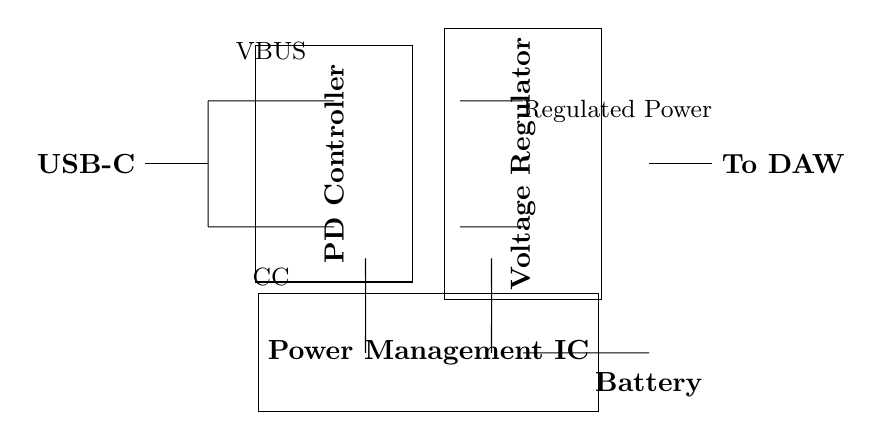What is the function of the PD Controller? The PD Controller (Power Delivery Controller) manages the negotiation of power levels and ensures that the correct power is delivered to connected devices.
Answer: Power management What component converts the voltage for device use? The Voltage Regulator adjusts the input voltage to a stable output voltage suitable for powering other components in the circuit.
Answer: Voltage Regulator What does VBUS represent in the circuit? VBUS is the line that carries the main power supply voltage in a USB connection and typically indicates a positive voltage level.
Answer: Main power supply How is the circuit powered? The circuit is powered through the Battery, supplying energy to the Power Management IC and subsequent components.
Answer: Battery What type of connection is used between the components? The circuit primarily uses short connections, indicated by the straight lines drawn between various components.
Answer: Short connections What role does the Power Management IC play in the circuit? The Power Management IC coordinates power distribution, allowing uniform and efficient distribution of energy from the battery to connected devices.
Answer: Power distribution 